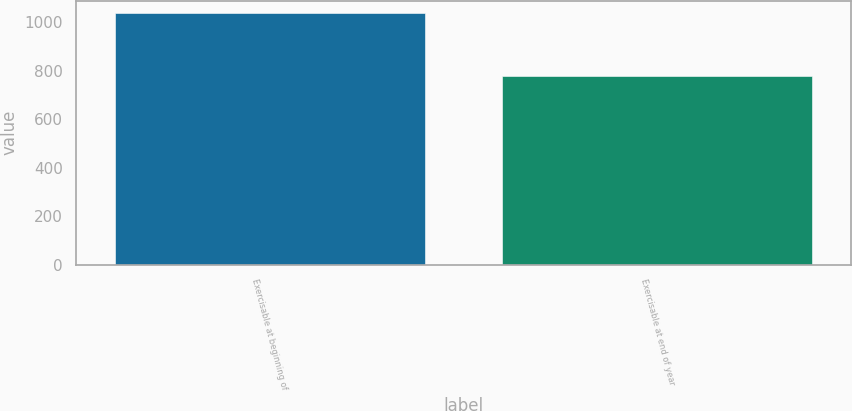Convert chart. <chart><loc_0><loc_0><loc_500><loc_500><bar_chart><fcel>Exercisable at beginning of<fcel>Exercisable at end of year<nl><fcel>1037.74<fcel>777.78<nl></chart> 